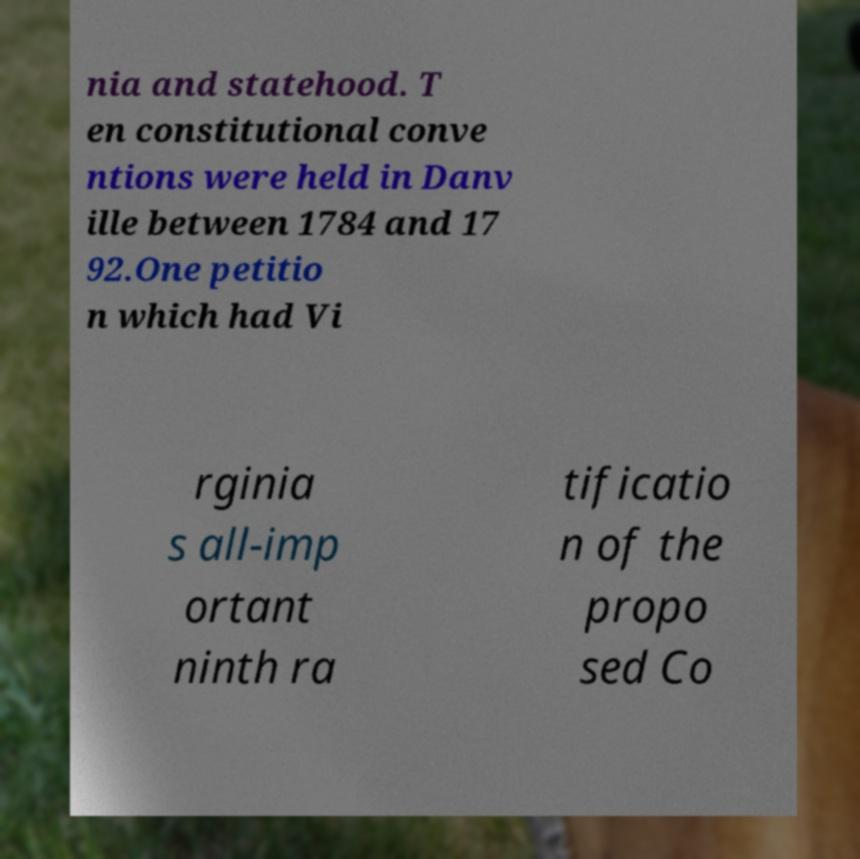Could you extract and type out the text from this image? nia and statehood. T en constitutional conve ntions were held in Danv ille between 1784 and 17 92.One petitio n which had Vi rginia s all-imp ortant ninth ra tificatio n of the propo sed Co 